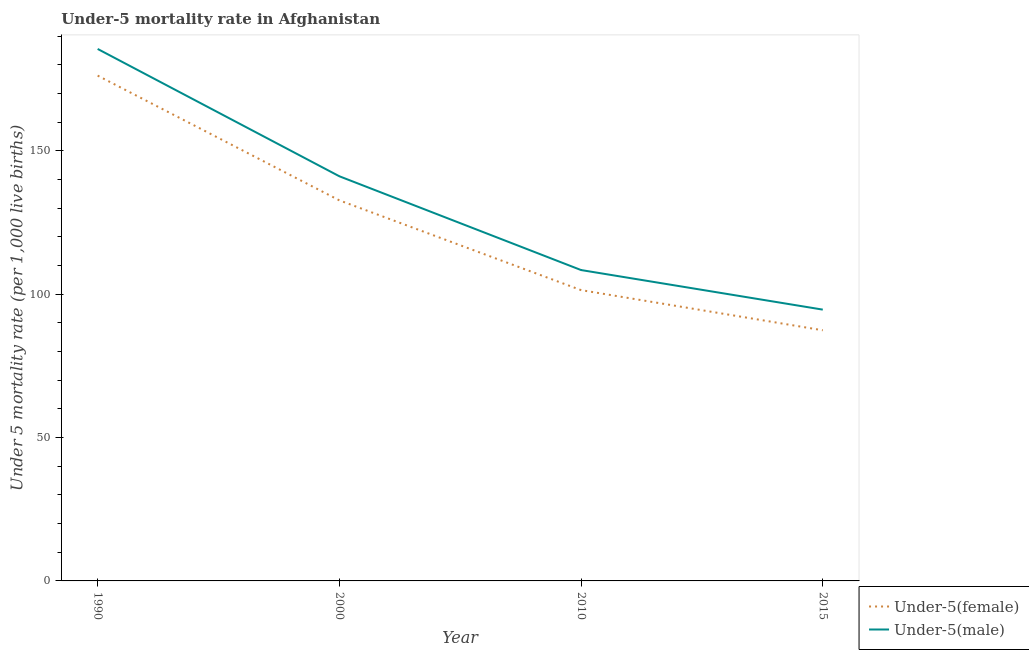What is the under-5 female mortality rate in 2015?
Give a very brief answer. 87.4. Across all years, what is the maximum under-5 female mortality rate?
Your answer should be compact. 176.2. Across all years, what is the minimum under-5 female mortality rate?
Offer a terse response. 87.4. In which year was the under-5 male mortality rate maximum?
Your answer should be very brief. 1990. In which year was the under-5 male mortality rate minimum?
Offer a very short reply. 2015. What is the total under-5 female mortality rate in the graph?
Offer a terse response. 497.7. What is the difference between the under-5 male mortality rate in 2000 and that in 2010?
Offer a terse response. 32.7. What is the difference between the under-5 male mortality rate in 2000 and the under-5 female mortality rate in 2010?
Your answer should be very brief. 39.7. What is the average under-5 male mortality rate per year?
Make the answer very short. 132.4. In the year 2015, what is the difference between the under-5 female mortality rate and under-5 male mortality rate?
Give a very brief answer. -7.2. In how many years, is the under-5 male mortality rate greater than 10?
Your response must be concise. 4. What is the ratio of the under-5 female mortality rate in 2000 to that in 2015?
Offer a terse response. 1.52. Is the under-5 male mortality rate in 2010 less than that in 2015?
Your response must be concise. No. What is the difference between the highest and the second highest under-5 male mortality rate?
Make the answer very short. 44.4. What is the difference between the highest and the lowest under-5 female mortality rate?
Give a very brief answer. 88.8. Does the under-5 male mortality rate monotonically increase over the years?
Your response must be concise. No. Is the under-5 female mortality rate strictly less than the under-5 male mortality rate over the years?
Provide a short and direct response. Yes. How many lines are there?
Keep it short and to the point. 2. What is the difference between two consecutive major ticks on the Y-axis?
Provide a short and direct response. 50. Are the values on the major ticks of Y-axis written in scientific E-notation?
Ensure brevity in your answer.  No. Does the graph contain grids?
Ensure brevity in your answer.  No. Where does the legend appear in the graph?
Offer a terse response. Bottom right. What is the title of the graph?
Ensure brevity in your answer.  Under-5 mortality rate in Afghanistan. Does "current US$" appear as one of the legend labels in the graph?
Offer a very short reply. No. What is the label or title of the Y-axis?
Give a very brief answer. Under 5 mortality rate (per 1,0 live births). What is the Under 5 mortality rate (per 1,000 live births) of Under-5(female) in 1990?
Provide a succinct answer. 176.2. What is the Under 5 mortality rate (per 1,000 live births) of Under-5(male) in 1990?
Your response must be concise. 185.5. What is the Under 5 mortality rate (per 1,000 live births) of Under-5(female) in 2000?
Provide a short and direct response. 132.7. What is the Under 5 mortality rate (per 1,000 live births) of Under-5(male) in 2000?
Ensure brevity in your answer.  141.1. What is the Under 5 mortality rate (per 1,000 live births) of Under-5(female) in 2010?
Give a very brief answer. 101.4. What is the Under 5 mortality rate (per 1,000 live births) of Under-5(male) in 2010?
Offer a terse response. 108.4. What is the Under 5 mortality rate (per 1,000 live births) in Under-5(female) in 2015?
Provide a succinct answer. 87.4. What is the Under 5 mortality rate (per 1,000 live births) of Under-5(male) in 2015?
Provide a short and direct response. 94.6. Across all years, what is the maximum Under 5 mortality rate (per 1,000 live births) of Under-5(female)?
Offer a terse response. 176.2. Across all years, what is the maximum Under 5 mortality rate (per 1,000 live births) of Under-5(male)?
Your response must be concise. 185.5. Across all years, what is the minimum Under 5 mortality rate (per 1,000 live births) of Under-5(female)?
Make the answer very short. 87.4. Across all years, what is the minimum Under 5 mortality rate (per 1,000 live births) of Under-5(male)?
Your response must be concise. 94.6. What is the total Under 5 mortality rate (per 1,000 live births) of Under-5(female) in the graph?
Provide a short and direct response. 497.7. What is the total Under 5 mortality rate (per 1,000 live births) of Under-5(male) in the graph?
Give a very brief answer. 529.6. What is the difference between the Under 5 mortality rate (per 1,000 live births) of Under-5(female) in 1990 and that in 2000?
Ensure brevity in your answer.  43.5. What is the difference between the Under 5 mortality rate (per 1,000 live births) of Under-5(male) in 1990 and that in 2000?
Make the answer very short. 44.4. What is the difference between the Under 5 mortality rate (per 1,000 live births) of Under-5(female) in 1990 and that in 2010?
Your response must be concise. 74.8. What is the difference between the Under 5 mortality rate (per 1,000 live births) in Under-5(male) in 1990 and that in 2010?
Your answer should be very brief. 77.1. What is the difference between the Under 5 mortality rate (per 1,000 live births) in Under-5(female) in 1990 and that in 2015?
Make the answer very short. 88.8. What is the difference between the Under 5 mortality rate (per 1,000 live births) of Under-5(male) in 1990 and that in 2015?
Ensure brevity in your answer.  90.9. What is the difference between the Under 5 mortality rate (per 1,000 live births) of Under-5(female) in 2000 and that in 2010?
Offer a terse response. 31.3. What is the difference between the Under 5 mortality rate (per 1,000 live births) of Under-5(male) in 2000 and that in 2010?
Make the answer very short. 32.7. What is the difference between the Under 5 mortality rate (per 1,000 live births) of Under-5(female) in 2000 and that in 2015?
Your response must be concise. 45.3. What is the difference between the Under 5 mortality rate (per 1,000 live births) in Under-5(male) in 2000 and that in 2015?
Provide a succinct answer. 46.5. What is the difference between the Under 5 mortality rate (per 1,000 live births) of Under-5(female) in 1990 and the Under 5 mortality rate (per 1,000 live births) of Under-5(male) in 2000?
Ensure brevity in your answer.  35.1. What is the difference between the Under 5 mortality rate (per 1,000 live births) in Under-5(female) in 1990 and the Under 5 mortality rate (per 1,000 live births) in Under-5(male) in 2010?
Make the answer very short. 67.8. What is the difference between the Under 5 mortality rate (per 1,000 live births) in Under-5(female) in 1990 and the Under 5 mortality rate (per 1,000 live births) in Under-5(male) in 2015?
Your response must be concise. 81.6. What is the difference between the Under 5 mortality rate (per 1,000 live births) in Under-5(female) in 2000 and the Under 5 mortality rate (per 1,000 live births) in Under-5(male) in 2010?
Provide a succinct answer. 24.3. What is the difference between the Under 5 mortality rate (per 1,000 live births) in Under-5(female) in 2000 and the Under 5 mortality rate (per 1,000 live births) in Under-5(male) in 2015?
Provide a succinct answer. 38.1. What is the average Under 5 mortality rate (per 1,000 live births) in Under-5(female) per year?
Your answer should be very brief. 124.42. What is the average Under 5 mortality rate (per 1,000 live births) of Under-5(male) per year?
Give a very brief answer. 132.4. In the year 2010, what is the difference between the Under 5 mortality rate (per 1,000 live births) in Under-5(female) and Under 5 mortality rate (per 1,000 live births) in Under-5(male)?
Your answer should be very brief. -7. What is the ratio of the Under 5 mortality rate (per 1,000 live births) of Under-5(female) in 1990 to that in 2000?
Give a very brief answer. 1.33. What is the ratio of the Under 5 mortality rate (per 1,000 live births) in Under-5(male) in 1990 to that in 2000?
Provide a succinct answer. 1.31. What is the ratio of the Under 5 mortality rate (per 1,000 live births) of Under-5(female) in 1990 to that in 2010?
Offer a terse response. 1.74. What is the ratio of the Under 5 mortality rate (per 1,000 live births) of Under-5(male) in 1990 to that in 2010?
Offer a very short reply. 1.71. What is the ratio of the Under 5 mortality rate (per 1,000 live births) in Under-5(female) in 1990 to that in 2015?
Make the answer very short. 2.02. What is the ratio of the Under 5 mortality rate (per 1,000 live births) of Under-5(male) in 1990 to that in 2015?
Your response must be concise. 1.96. What is the ratio of the Under 5 mortality rate (per 1,000 live births) in Under-5(female) in 2000 to that in 2010?
Ensure brevity in your answer.  1.31. What is the ratio of the Under 5 mortality rate (per 1,000 live births) in Under-5(male) in 2000 to that in 2010?
Ensure brevity in your answer.  1.3. What is the ratio of the Under 5 mortality rate (per 1,000 live births) in Under-5(female) in 2000 to that in 2015?
Keep it short and to the point. 1.52. What is the ratio of the Under 5 mortality rate (per 1,000 live births) in Under-5(male) in 2000 to that in 2015?
Your answer should be compact. 1.49. What is the ratio of the Under 5 mortality rate (per 1,000 live births) in Under-5(female) in 2010 to that in 2015?
Make the answer very short. 1.16. What is the ratio of the Under 5 mortality rate (per 1,000 live births) of Under-5(male) in 2010 to that in 2015?
Your response must be concise. 1.15. What is the difference between the highest and the second highest Under 5 mortality rate (per 1,000 live births) in Under-5(female)?
Your answer should be compact. 43.5. What is the difference between the highest and the second highest Under 5 mortality rate (per 1,000 live births) in Under-5(male)?
Provide a succinct answer. 44.4. What is the difference between the highest and the lowest Under 5 mortality rate (per 1,000 live births) of Under-5(female)?
Your response must be concise. 88.8. What is the difference between the highest and the lowest Under 5 mortality rate (per 1,000 live births) in Under-5(male)?
Keep it short and to the point. 90.9. 